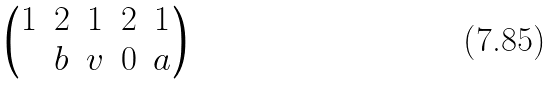Convert formula to latex. <formula><loc_0><loc_0><loc_500><loc_500>\begin{pmatrix} 1 & 2 & 1 & 2 & 1 \\ & b & v & 0 & a \end{pmatrix}</formula> 